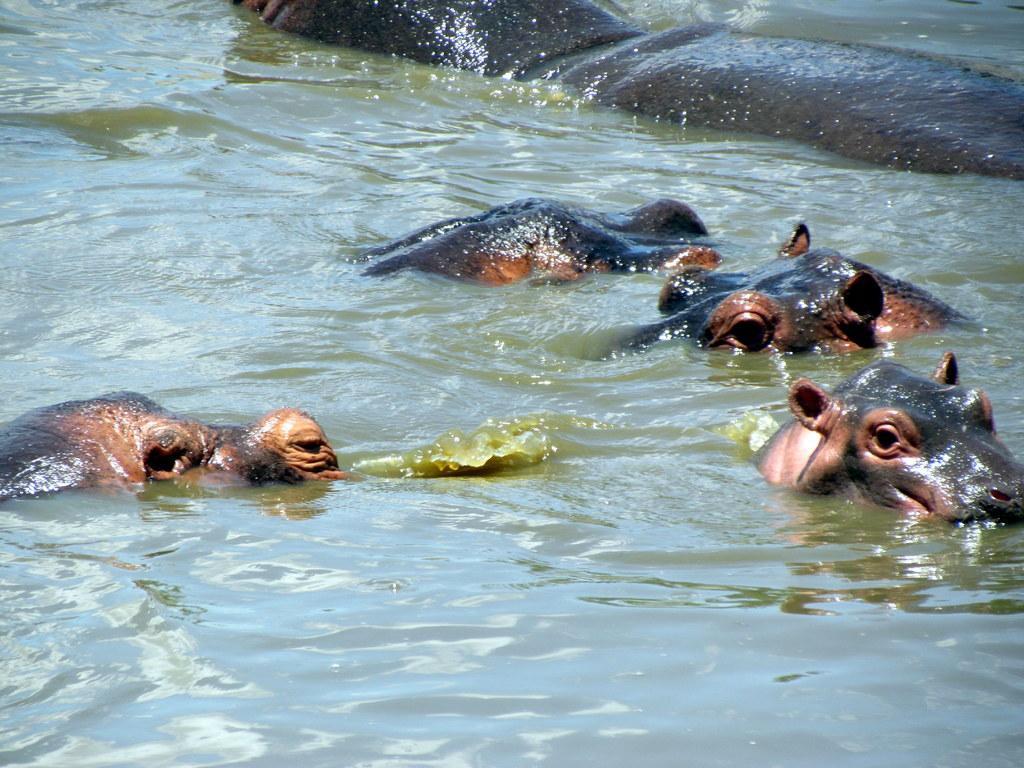Could you give a brief overview of what you see in this image? In this picture we can observe hippopotamuses swimming in the water. They are in brown color. 